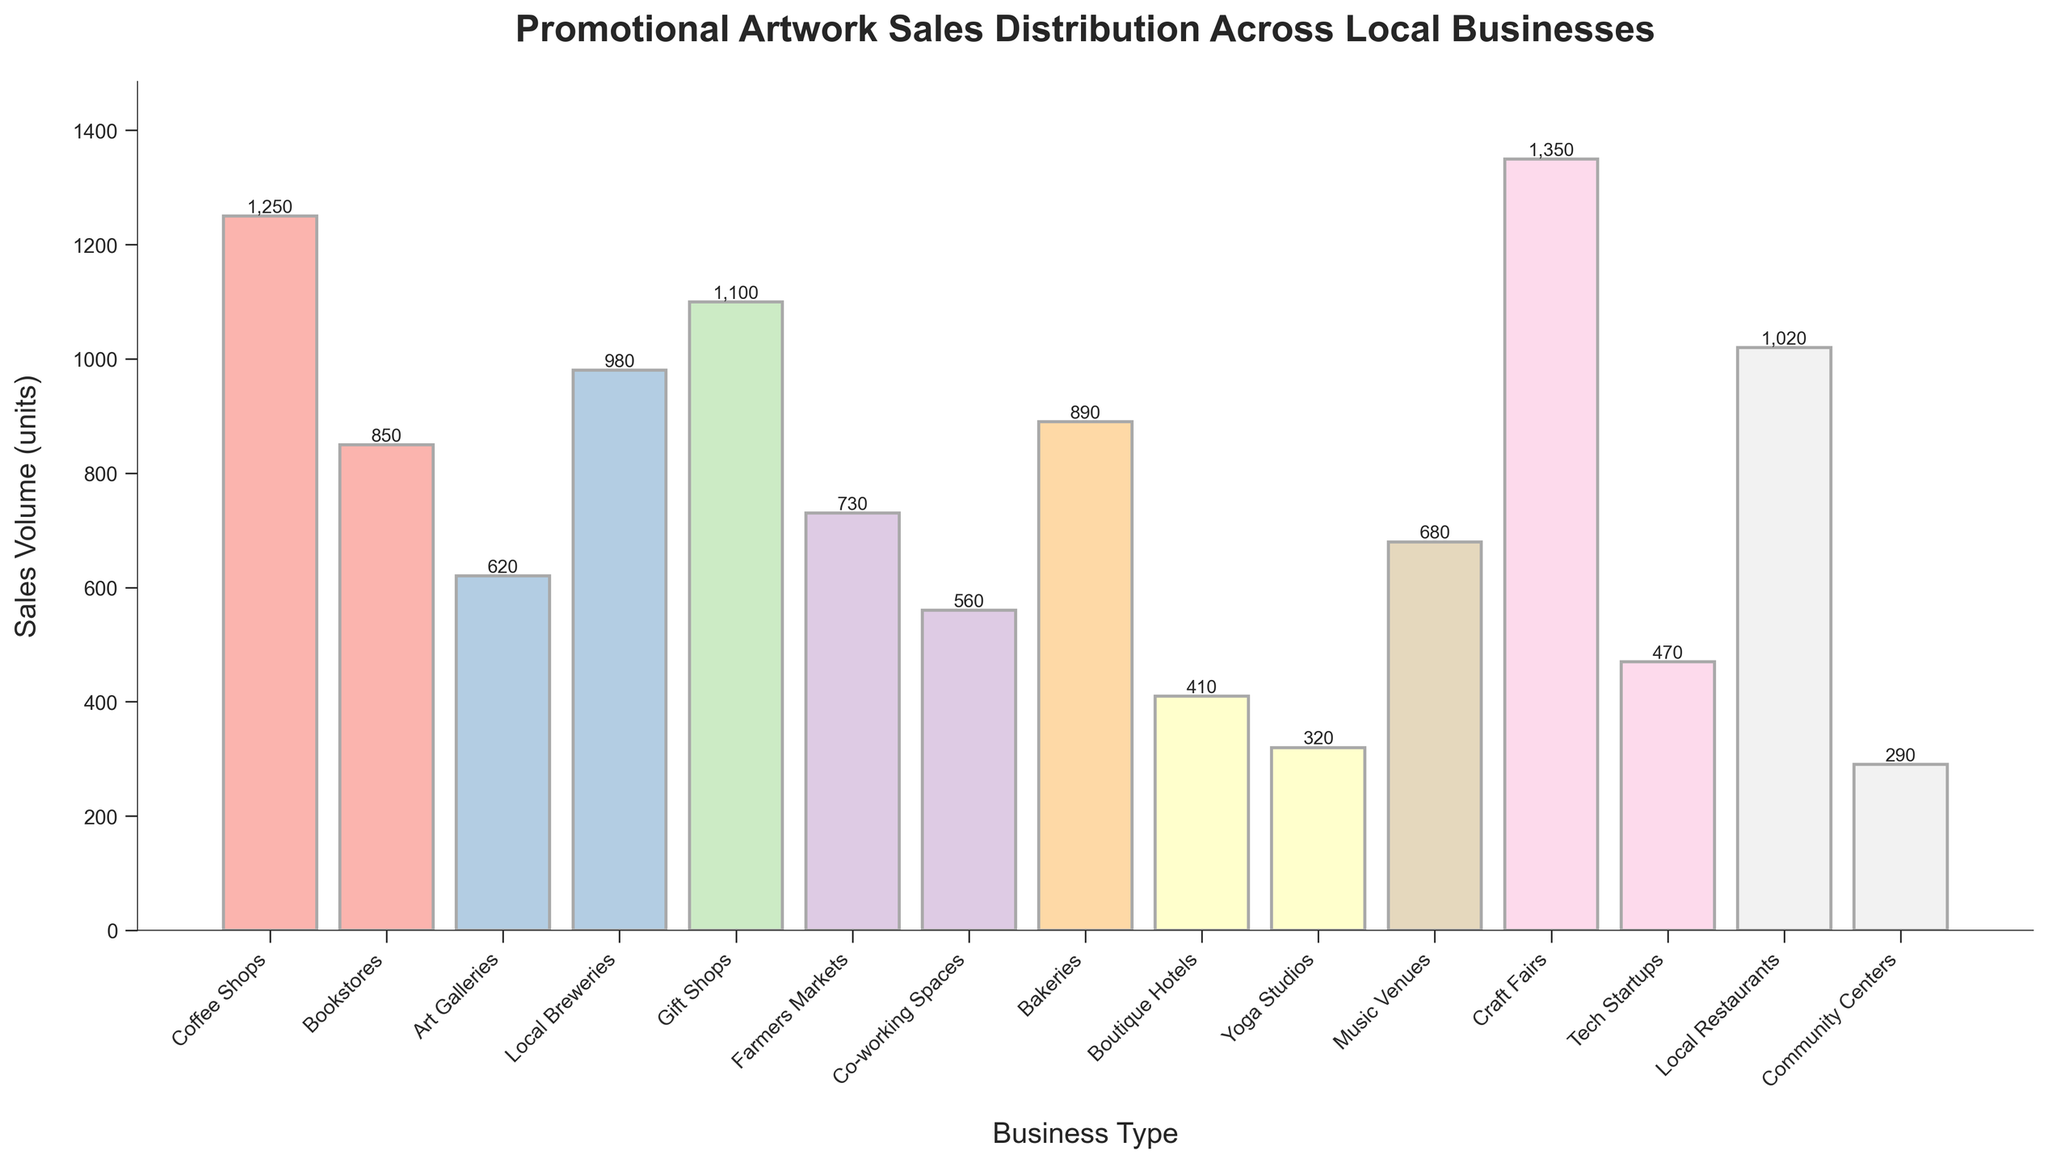Which business type has the highest sales volume? The business type with the highest bar represents the highest sales volume. The bar representing Craft Fairs is the tallest.
Answer: Craft Fairs Which business type has the lowest sales volume? The business type with the lowest bar represents the lowest sales volume. The bar representing Community Centers is the shortest.
Answer: Community Centers What is the difference in sales volume between Coffee Shops and Local Breweries? The sales volume for Coffee Shops is 1250 units and for Local Breweries is 980 units. The difference is 1250 - 980.
Answer: 270 units What is the total sales volume for Bookstores, Bakeries, and Yoga Studios combined? The sales volumes for Bookstores, Bakeries, and Yoga Studios are 850, 890, and 320 units respectively. Sum them up to get the total: 850 + 890 + 320.
Answer: 2060 units Which business type categories fall between 700 and 900 units in sales volume? Visually identify the business types with bars that have heights between 700 and 900. These are Farmers Markets, Music Venues, and Bakeries.
Answer: Farmers Markets, Music Venues, and Bakeries Are there more businesses with sales volumes above 1000 units or below 500 units? Count the number of businesses with sales volumes above 1000 units (Coffee Shops, Craft Fairs, Gift Shops, Local Restaurants) which is 4, and count those below 500 units (Boutique Hotels, Yoga Studios, Tech Startups, Community Centers) which is also 4.
Answer: Equal What is the average sales volume across all business types? Add up all the sales volumes and divide by the number of businesses: (1250 + 850 + 620 + 980 + 1100 + 730 + 560 + 890 + 410 + 320 + 680 + 1350 + 470 + 1020 + 290) / 15.
Answer: 792 units Which two business types have the closest sales volumes? Visually compare the height of the bars, focus on pairs with minimal visible difference. Coffee Shops and Local Restaurants both have bars very close in height, with sales volumes of 1250 and 1020 respectively. Another pair might be Bakeries and Bookstores (890 and 850 respectively). The former (Coffee Shops and Local Restaurants) have closer values.
Answer: Coffee Shops and Local Restaurants (230 units) What is the combined sales volume of the top 3 business types? Identify the top 3 business types by the highest bars: Craft Fairs (1350), Coffee Shops (1250), and Gift Shops (1100). Sum them: 1350 + 1250 + 1100.
Answer: 3700 units How many business types have sales volumes between 500 and 1000 units? Count the bars whose heights fall between 500 and 1000 units. These include Art Galleries, Local Breweries, Farmers Markets, Music Venues, and Bakeries.
Answer: 5 